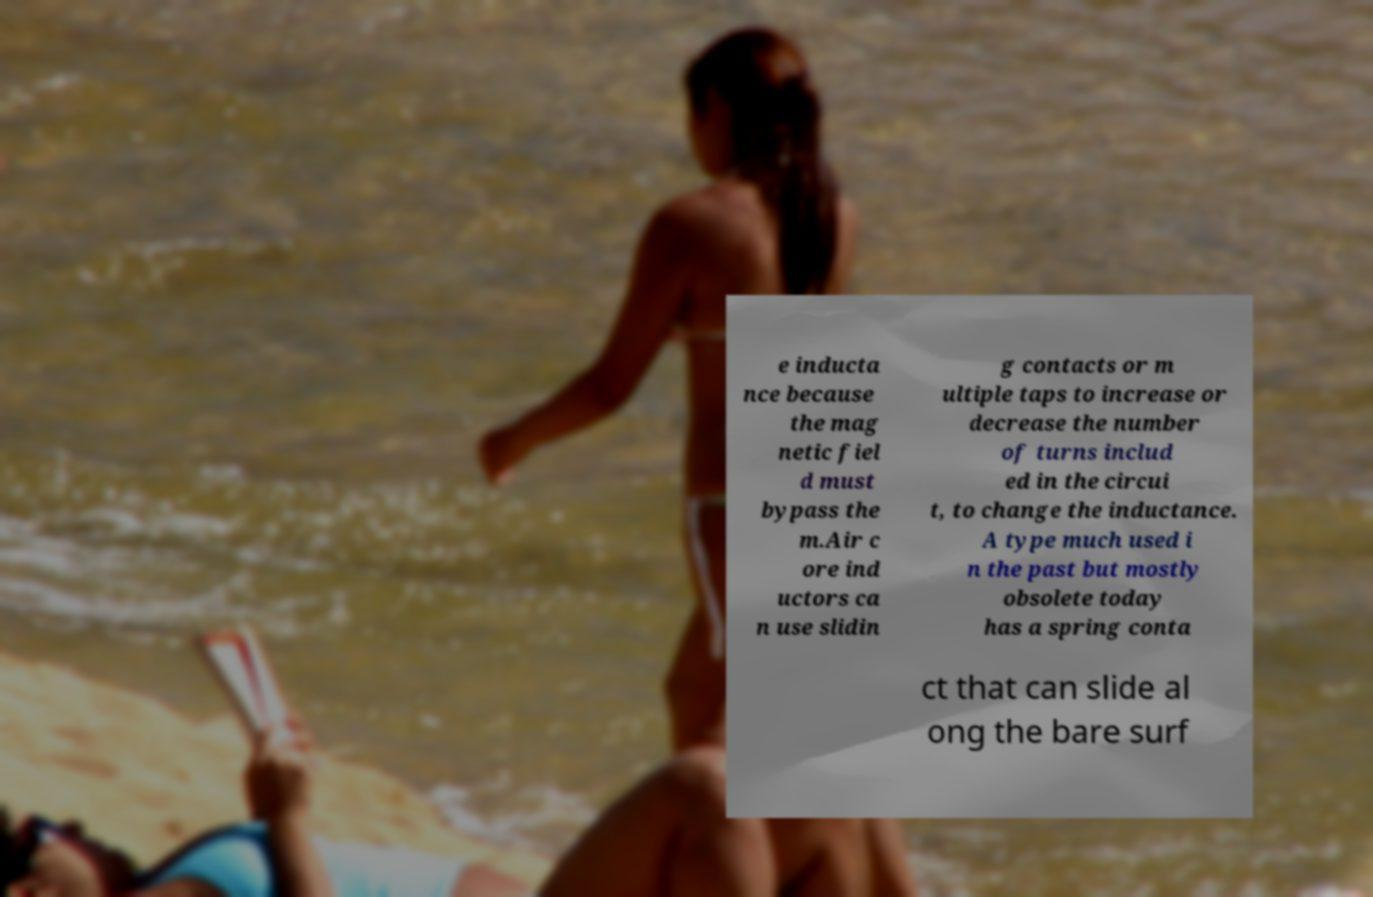Could you assist in decoding the text presented in this image and type it out clearly? e inducta nce because the mag netic fiel d must bypass the m.Air c ore ind uctors ca n use slidin g contacts or m ultiple taps to increase or decrease the number of turns includ ed in the circui t, to change the inductance. A type much used i n the past but mostly obsolete today has a spring conta ct that can slide al ong the bare surf 